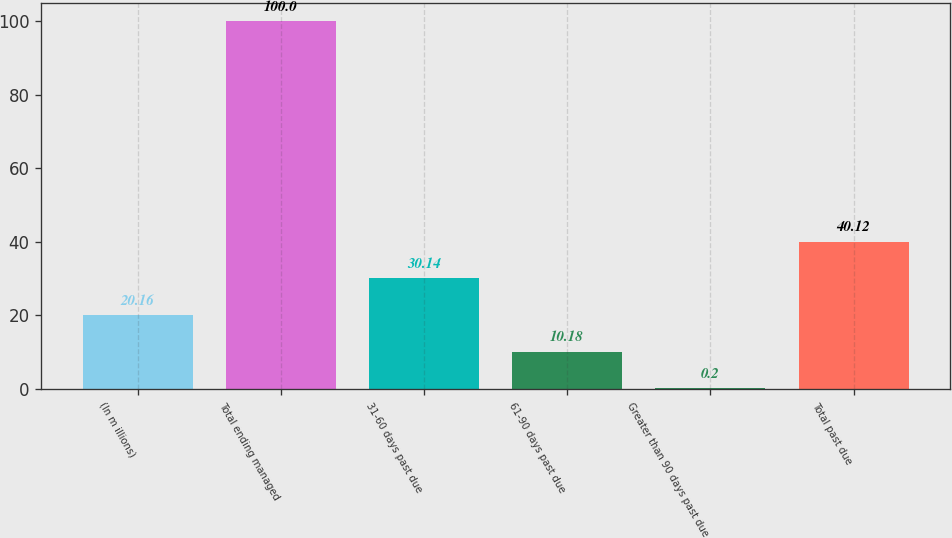<chart> <loc_0><loc_0><loc_500><loc_500><bar_chart><fcel>(In m illions)<fcel>Total ending managed<fcel>31-60 days past due<fcel>61-90 days past due<fcel>Greater than 90 days past due<fcel>Total past due<nl><fcel>20.16<fcel>100<fcel>30.14<fcel>10.18<fcel>0.2<fcel>40.12<nl></chart> 